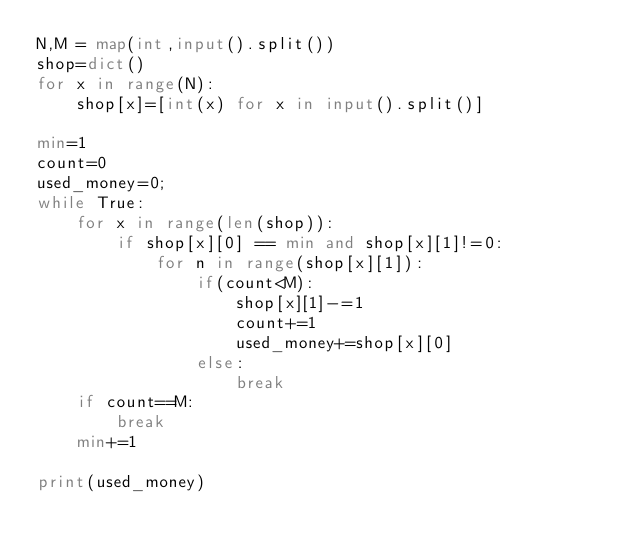<code> <loc_0><loc_0><loc_500><loc_500><_Python_>N,M = map(int,input().split())
shop=dict()
for x in range(N):
    shop[x]=[int(x) for x in input().split()]

min=1
count=0
used_money=0;
while True:
    for x in range(len(shop)):
        if shop[x][0] == min and shop[x][1]!=0:
            for n in range(shop[x][1]):
                if(count<M):
                    shop[x][1]-=1
                    count+=1
                    used_money+=shop[x][0]
                else:
                    break
    if count==M:
        break       
    min+=1
    
print(used_money)</code> 